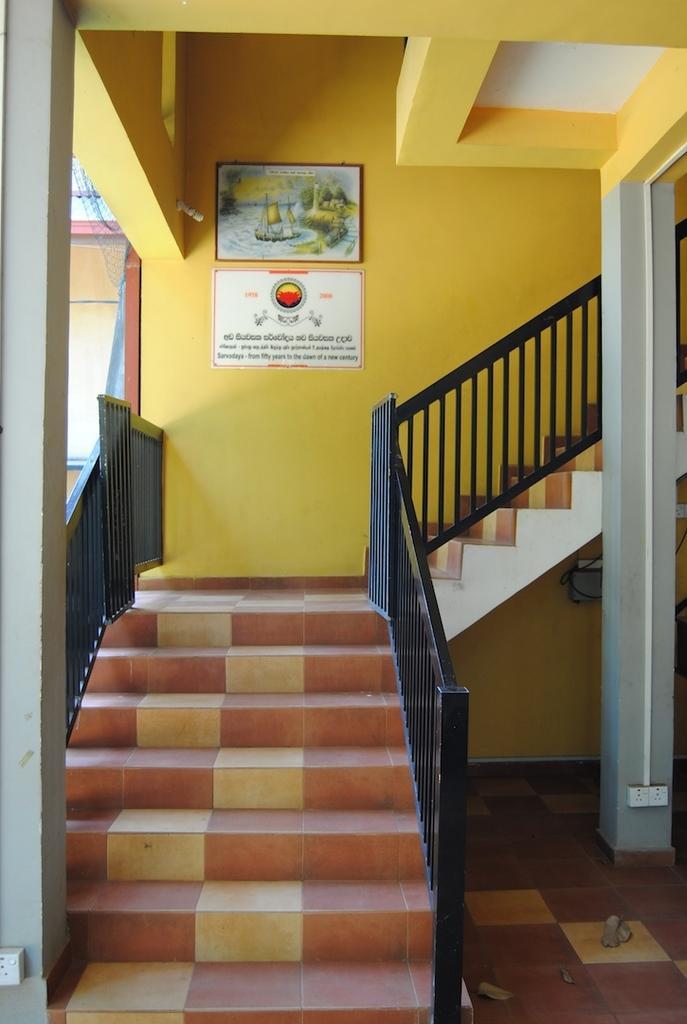Can you describe this image briefly? In this image there are stairs to the upper floor of a building and also some boards on the wall. 